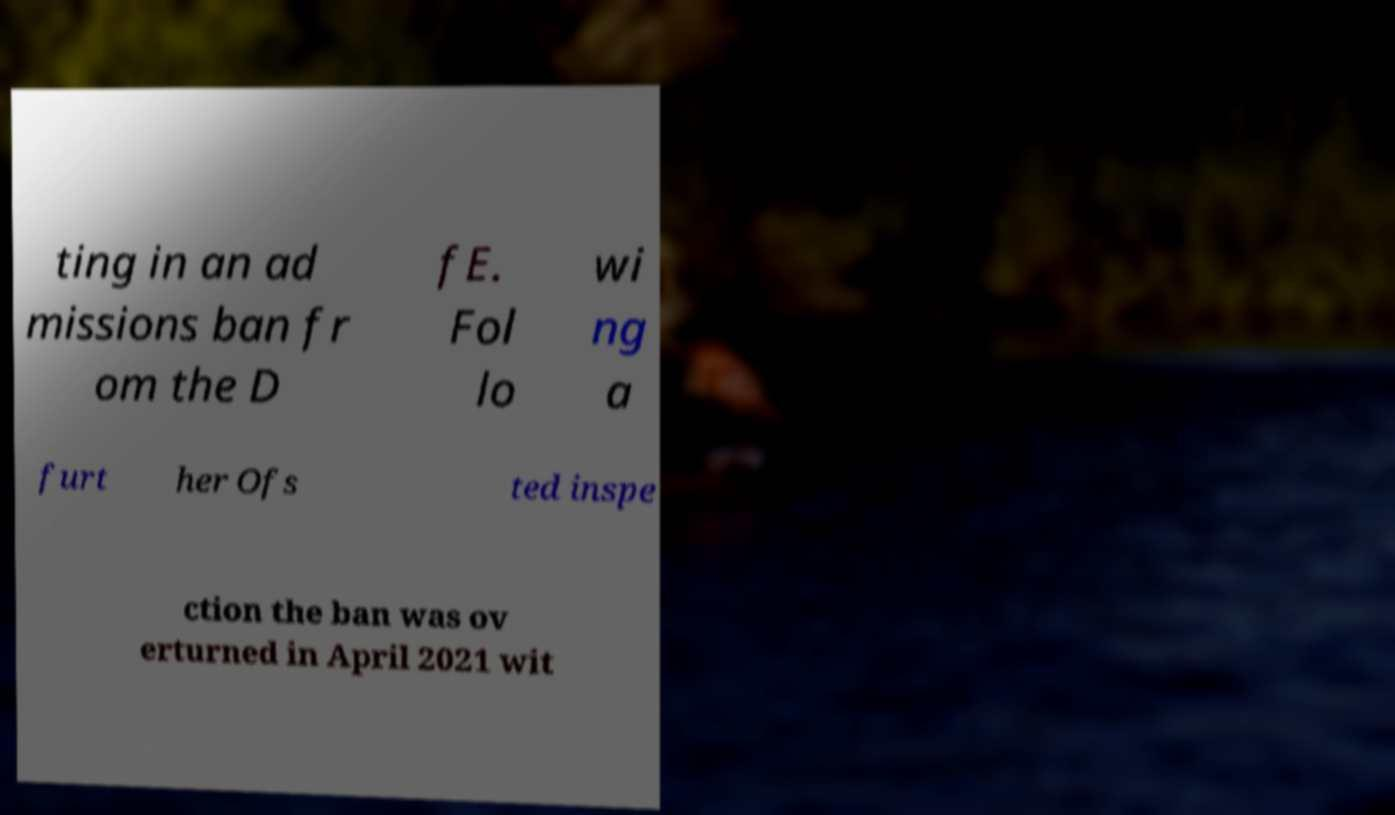Please read and relay the text visible in this image. What does it say? ting in an ad missions ban fr om the D fE. Fol lo wi ng a furt her Ofs ted inspe ction the ban was ov erturned in April 2021 wit 